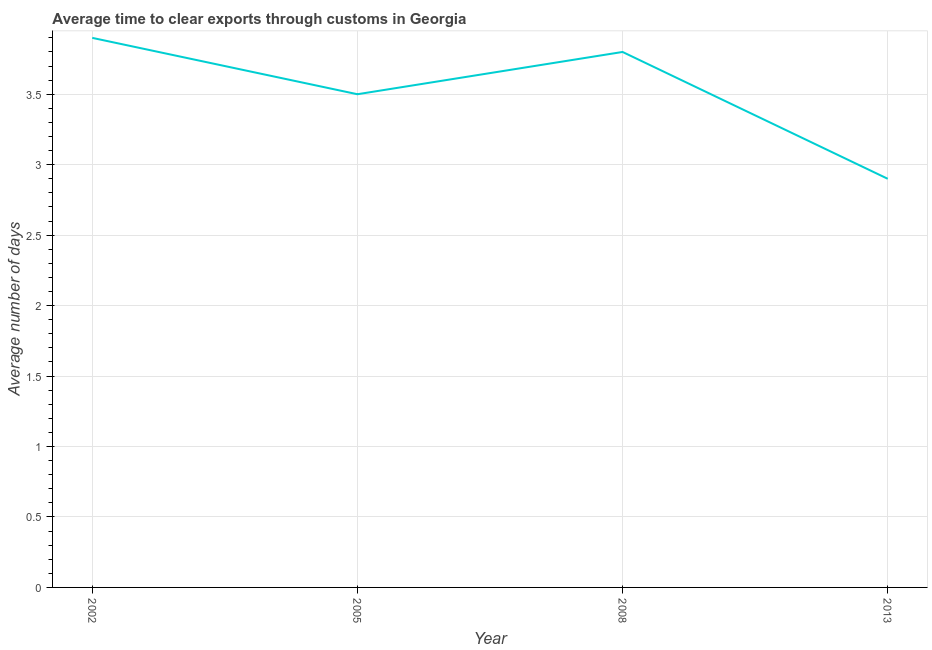Across all years, what is the minimum time to clear exports through customs?
Your answer should be compact. 2.9. In which year was the time to clear exports through customs maximum?
Keep it short and to the point. 2002. What is the difference between the time to clear exports through customs in 2005 and 2013?
Offer a terse response. 0.6. What is the average time to clear exports through customs per year?
Keep it short and to the point. 3.52. What is the median time to clear exports through customs?
Provide a succinct answer. 3.65. Do a majority of the years between 2013 and 2008 (inclusive) have time to clear exports through customs greater than 3.5 days?
Provide a succinct answer. No. What is the ratio of the time to clear exports through customs in 2002 to that in 2013?
Your answer should be very brief. 1.34. Is the difference between the time to clear exports through customs in 2008 and 2013 greater than the difference between any two years?
Keep it short and to the point. No. What is the difference between the highest and the second highest time to clear exports through customs?
Make the answer very short. 0.1. Is the sum of the time to clear exports through customs in 2005 and 2008 greater than the maximum time to clear exports through customs across all years?
Offer a very short reply. Yes. In how many years, is the time to clear exports through customs greater than the average time to clear exports through customs taken over all years?
Offer a very short reply. 2. How many lines are there?
Your answer should be very brief. 1. How many years are there in the graph?
Make the answer very short. 4. What is the title of the graph?
Ensure brevity in your answer.  Average time to clear exports through customs in Georgia. What is the label or title of the X-axis?
Give a very brief answer. Year. What is the label or title of the Y-axis?
Your answer should be compact. Average number of days. What is the Average number of days in 2005?
Your response must be concise. 3.5. What is the Average number of days in 2008?
Offer a very short reply. 3.8. What is the difference between the Average number of days in 2002 and 2008?
Provide a succinct answer. 0.1. What is the difference between the Average number of days in 2002 and 2013?
Ensure brevity in your answer.  1. What is the difference between the Average number of days in 2005 and 2013?
Offer a very short reply. 0.6. What is the ratio of the Average number of days in 2002 to that in 2005?
Make the answer very short. 1.11. What is the ratio of the Average number of days in 2002 to that in 2013?
Provide a succinct answer. 1.34. What is the ratio of the Average number of days in 2005 to that in 2008?
Give a very brief answer. 0.92. What is the ratio of the Average number of days in 2005 to that in 2013?
Your answer should be compact. 1.21. What is the ratio of the Average number of days in 2008 to that in 2013?
Give a very brief answer. 1.31. 